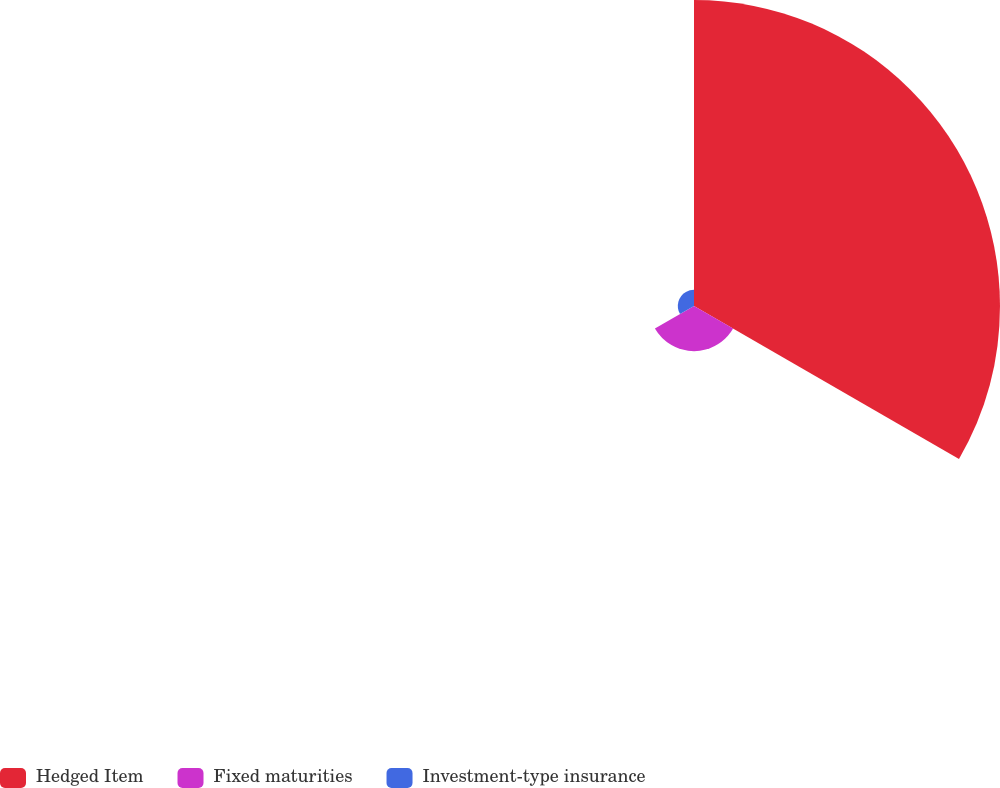Convert chart to OTSL. <chart><loc_0><loc_0><loc_500><loc_500><pie_chart><fcel>Hedged Item<fcel>Fixed maturities<fcel>Investment-type insurance<nl><fcel>83.3%<fcel>12.29%<fcel>4.4%<nl></chart> 